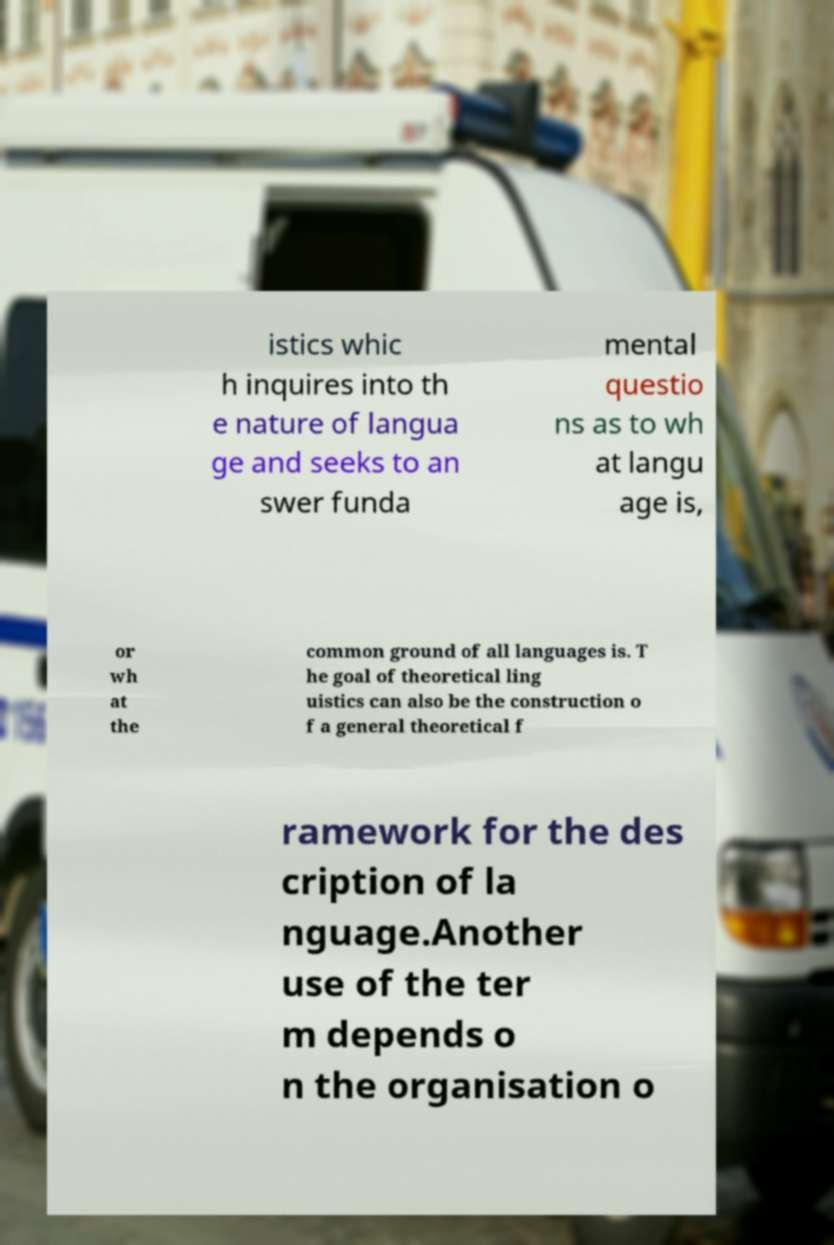What messages or text are displayed in this image? I need them in a readable, typed format. istics whic h inquires into th e nature of langua ge and seeks to an swer funda mental questio ns as to wh at langu age is, or wh at the common ground of all languages is. T he goal of theoretical ling uistics can also be the construction o f a general theoretical f ramework for the des cription of la nguage.Another use of the ter m depends o n the organisation o 